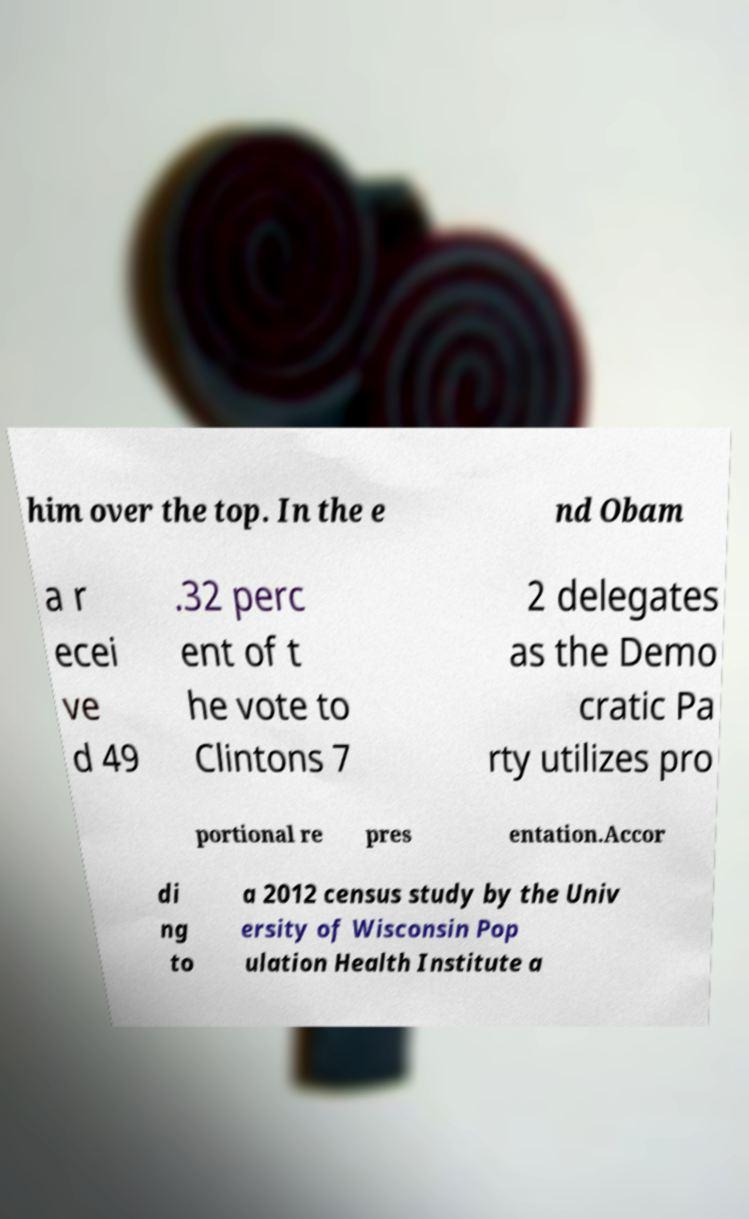Can you read and provide the text displayed in the image?This photo seems to have some interesting text. Can you extract and type it out for me? him over the top. In the e nd Obam a r ecei ve d 49 .32 perc ent of t he vote to Clintons 7 2 delegates as the Demo cratic Pa rty utilizes pro portional re pres entation.Accor di ng to a 2012 census study by the Univ ersity of Wisconsin Pop ulation Health Institute a 